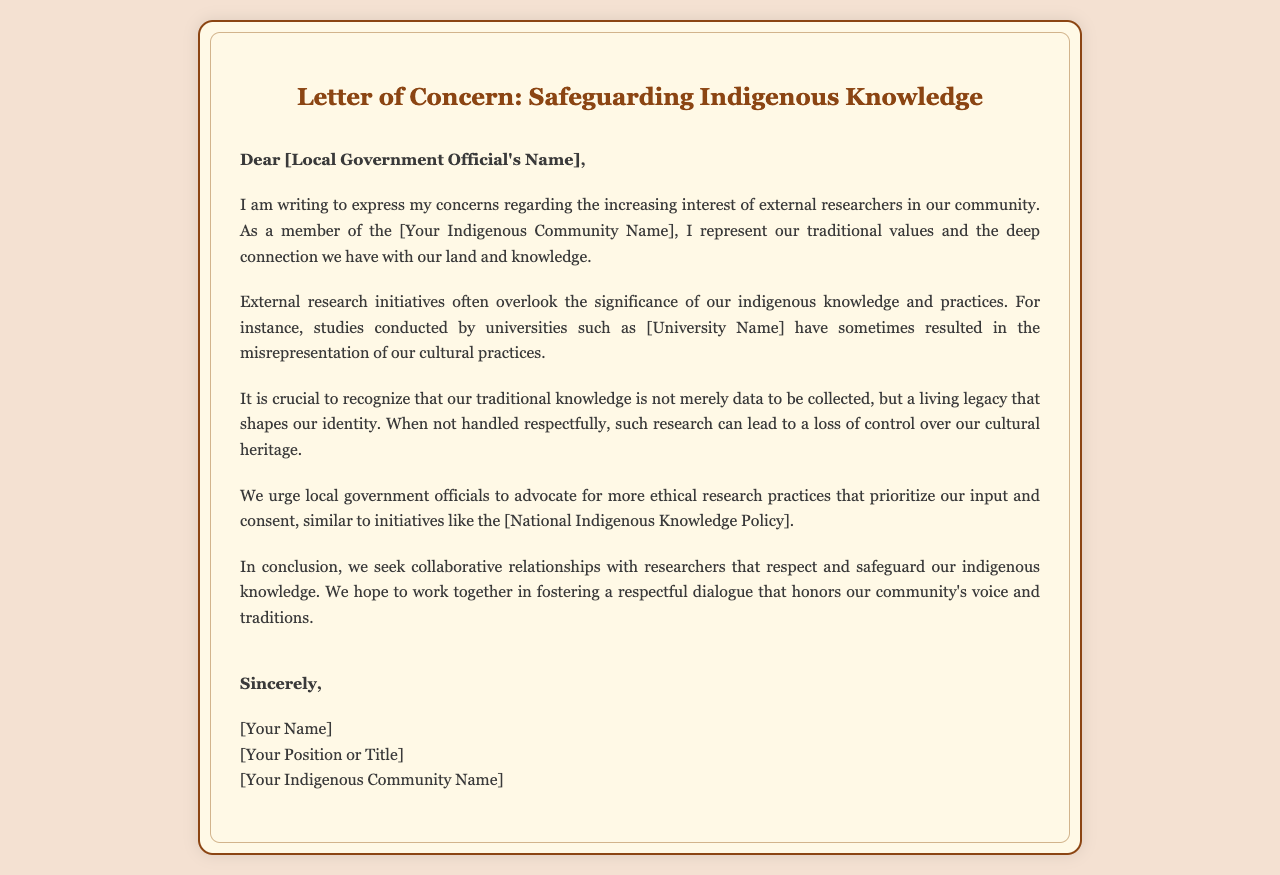what is the title of the letter? The title is stated at the top of the document.
Answer: Letter of Concern: Safeguarding Indigenous Knowledge who is the letter addressed to? The letter is addressed to a specific local government official, whose name would be included in the designated area.
Answer: [Local Government Official's Name] what does the author represent? The author mentions representing traditional values and a connection with their land and knowledge.
Answer: [Your Indigenous Community Name] which university is mentioned as conducting studies? The letter references a university that has been involved in research, although it doesn't provide a specific name here.
Answer: [University Name] what is emphasized as being a living legacy? The author discusses a concept that is integral to their identity, which should be handled with care.
Answer: traditional knowledge what do the authors urge local officials to advocate for? The letter requests a specific approach to research practices relating to indigenous communities.
Answer: ethical research practices what is mentioned as a similar initiative to be considered? A policy or initiative is suggested that aligns with the letter's request for ethical treatment.
Answer: [National Indigenous Knowledge Policy] who signs off the letter? The letter concludes with the identity of the person representing their community, including their title.
Answer: [Your Name], [Your Position or Title], [Your Indigenous Community Name] how is the closing salutation phrased? The closing section conveys the author's final remarks before signing.
Answer: Sincerely 